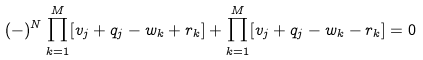<formula> <loc_0><loc_0><loc_500><loc_500>( - ) ^ { N } \prod _ { k = 1 } ^ { M } [ v _ { j } + q _ { j } - w _ { k } + r _ { k } ] + \prod _ { k = 1 } ^ { M } [ v _ { j } + q _ { j } - w _ { k } - r _ { k } ] = 0</formula> 